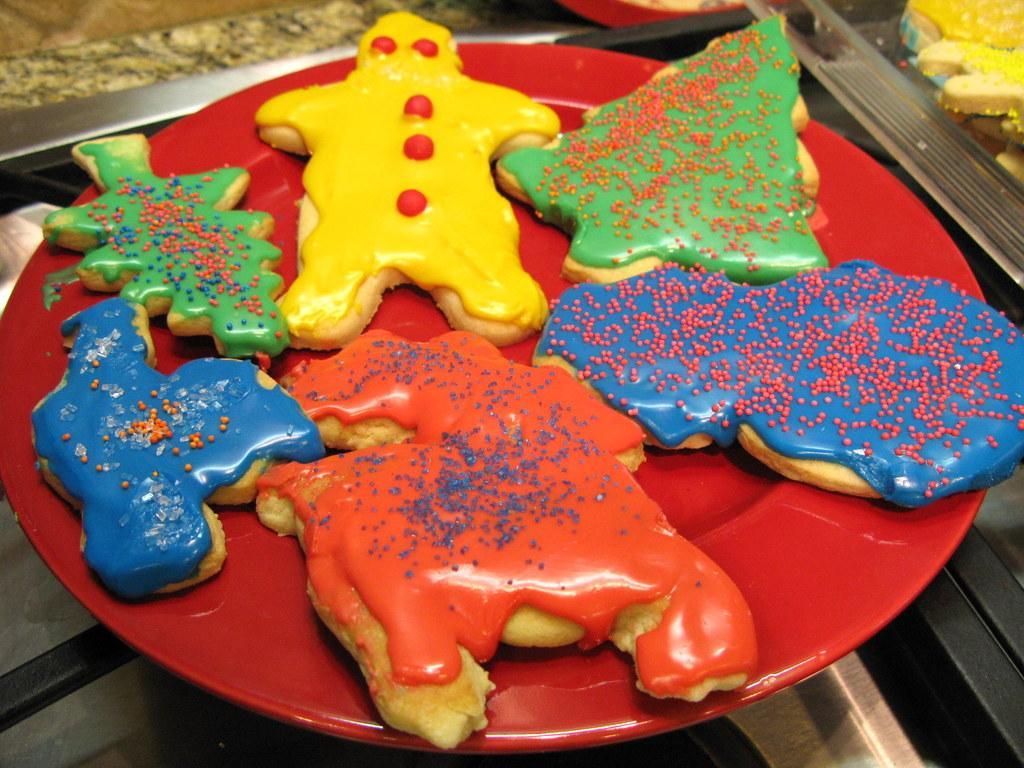Please provide a concise description of this image. In this image we can see a plate with some food on the table. 